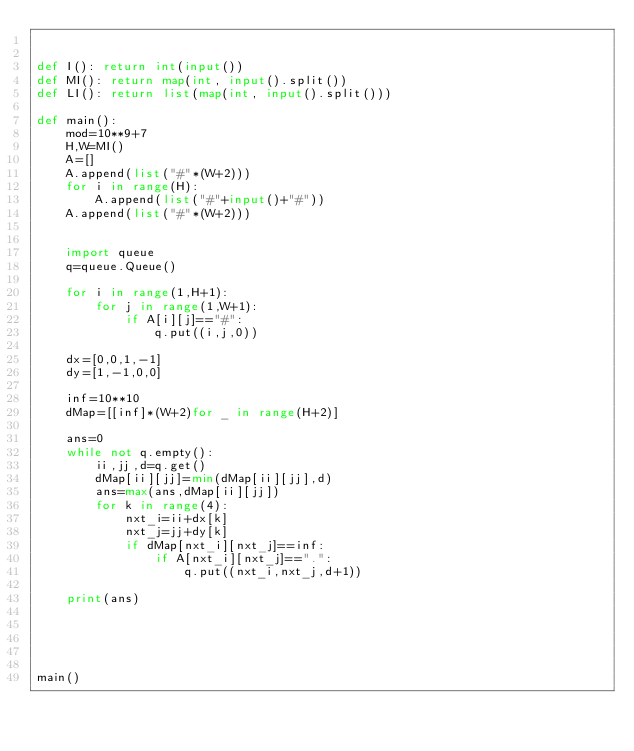Convert code to text. <code><loc_0><loc_0><loc_500><loc_500><_Python_>

def I(): return int(input())
def MI(): return map(int, input().split())
def LI(): return list(map(int, input().split()))

def main():
    mod=10**9+7
    H,W=MI()
    A=[]
    A.append(list("#"*(W+2)))
    for i in range(H):
        A.append(list("#"+input()+"#"))
    A.append(list("#"*(W+2)))
    
    
    import queue
    q=queue.Queue()
    
    for i in range(1,H+1):
        for j in range(1,W+1):
            if A[i][j]=="#":
                q.put((i,j,0))
    
    dx=[0,0,1,-1]
    dy=[1,-1,0,0]
    
    inf=10**10
    dMap=[[inf]*(W+2)for _ in range(H+2)]
    
    ans=0
    while not q.empty():
        ii,jj,d=q.get()
        dMap[ii][jj]=min(dMap[ii][jj],d)
        ans=max(ans,dMap[ii][jj])
        for k in range(4):
            nxt_i=ii+dx[k]
            nxt_j=jj+dy[k]
            if dMap[nxt_i][nxt_j]==inf:
                if A[nxt_i][nxt_j]==".":
                    q.put((nxt_i,nxt_j,d+1))
                
    print(ans)
                
                
    
            

main()
</code> 